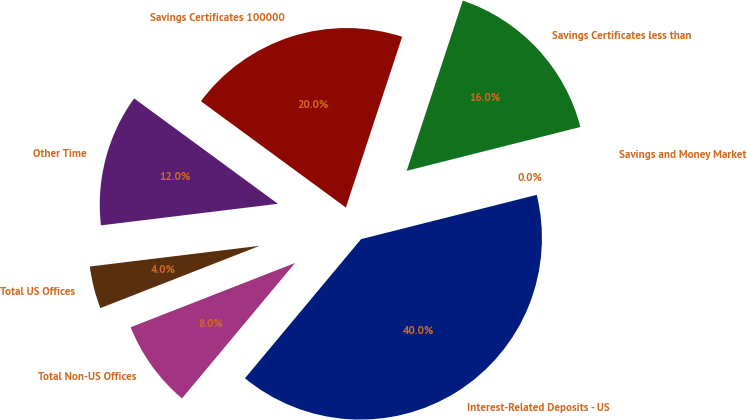Convert chart to OTSL. <chart><loc_0><loc_0><loc_500><loc_500><pie_chart><fcel>Interest-Related Deposits - US<fcel>Savings and Money Market<fcel>Savings Certificates less than<fcel>Savings Certificates 100000<fcel>Other Time<fcel>Total US Offices<fcel>Total Non-US Offices<nl><fcel>40.0%<fcel>0.0%<fcel>16.0%<fcel>20.0%<fcel>12.0%<fcel>4.0%<fcel>8.0%<nl></chart> 